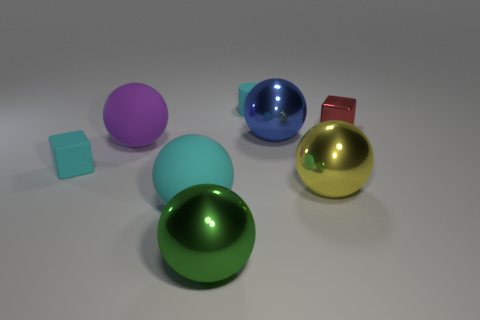What size is the matte block that is the same color as the tiny cylinder?
Make the answer very short. Small. What number of blocks are small cyan rubber objects or large yellow objects?
Give a very brief answer. 1. The object on the right side of the yellow thing is what color?
Make the answer very short. Red. There is a tiny rubber object that is the same color as the rubber cube; what is its shape?
Ensure brevity in your answer.  Cylinder. What number of cyan things have the same size as the metallic block?
Offer a terse response. 2. Do the thing on the left side of the purple object and the tiny cyan matte object behind the big blue thing have the same shape?
Provide a short and direct response. No. What material is the cyan thing to the right of the large green sphere in front of the cyan cylinder that is on the right side of the purple matte sphere?
Your answer should be compact. Rubber. There is a purple matte thing that is the same size as the blue metal sphere; what shape is it?
Provide a succinct answer. Sphere. Are there any tiny cylinders that have the same color as the metallic cube?
Your answer should be compact. No. What size is the matte cube?
Offer a very short reply. Small. 